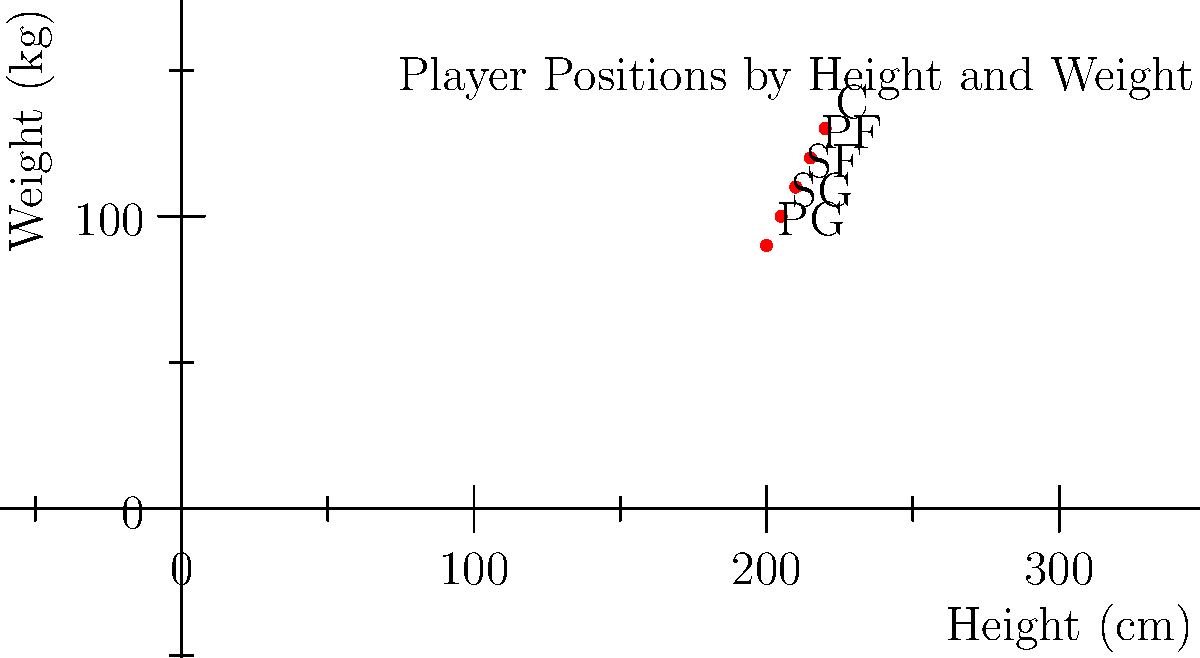Based on the scatter plot of NBA 2K player positions by height and weight, which position is typically associated with the tallest and heaviest players? To answer this question, we need to analyze the scatter plot:

1. The x-axis represents height in centimeters, and the y-axis represents weight in kilograms.
2. Each point on the plot represents a typical player for a specific position, labeled with the position abbreviation.
3. The positions shown are PG (Point Guard), SG (Shooting Guard), SF (Small Forward), PF (Power Forward), and C (Center).
4. Observing the plot, we can see that the points form a diagonal line from bottom-left to top-right.
5. This diagonal arrangement indicates that as we move from PG to C, both height and weight tend to increase.
6. The point labeled "C" is at the top-right corner of the plot, representing the tallest and heaviest position.

Therefore, the position typically associated with the tallest and heaviest players is the Center (C).
Answer: Center (C) 